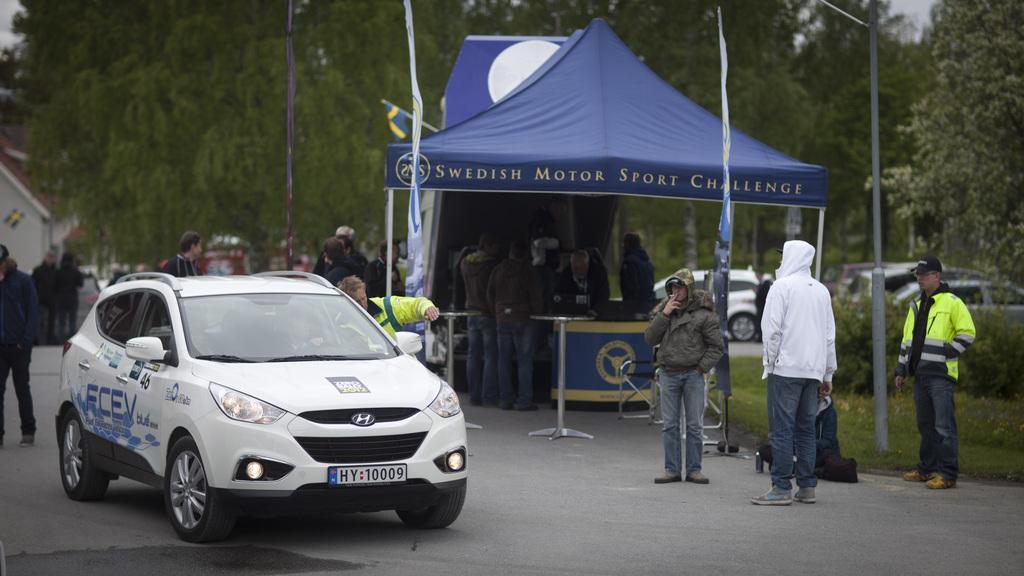Can you describe this image briefly? There is a white color car and people are present as we can see at the bottom of this image. We can see a tent in the middle of this image. There are trees in the background. 